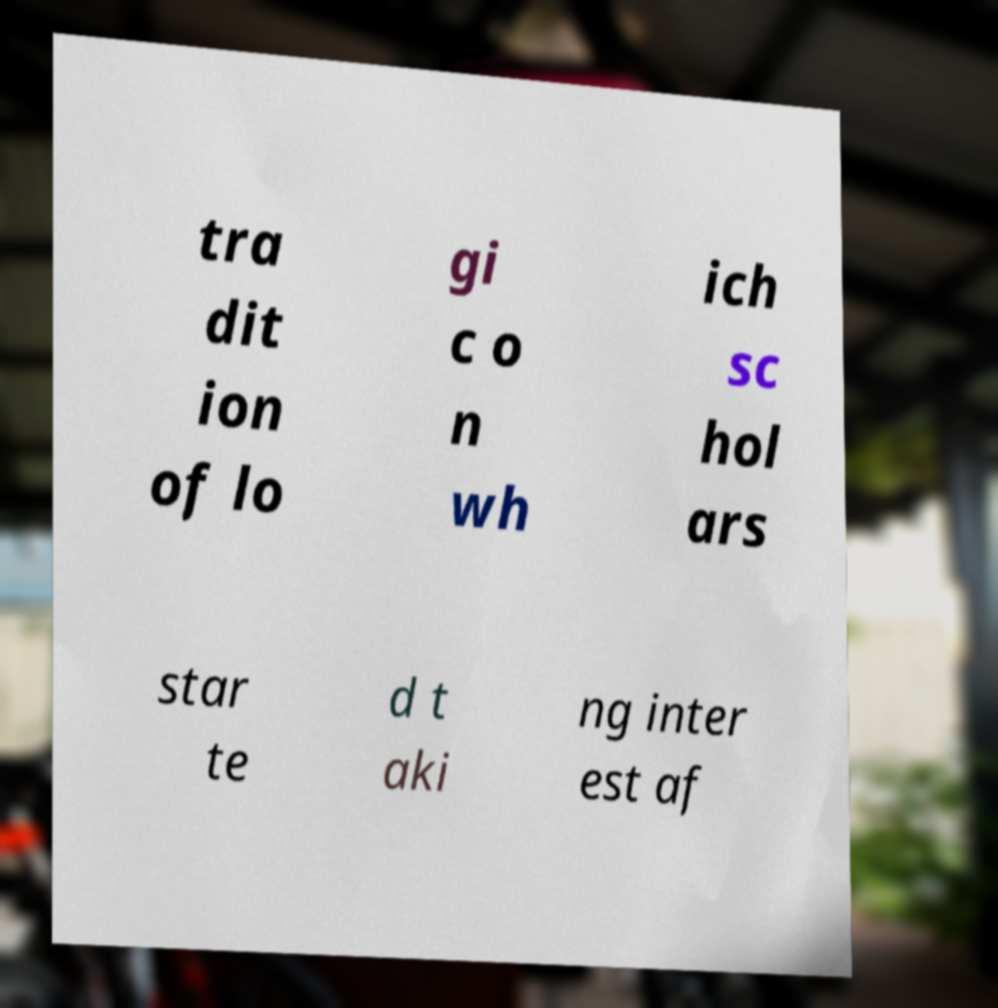Please identify and transcribe the text found in this image. tra dit ion of lo gi c o n wh ich sc hol ars star te d t aki ng inter est af 